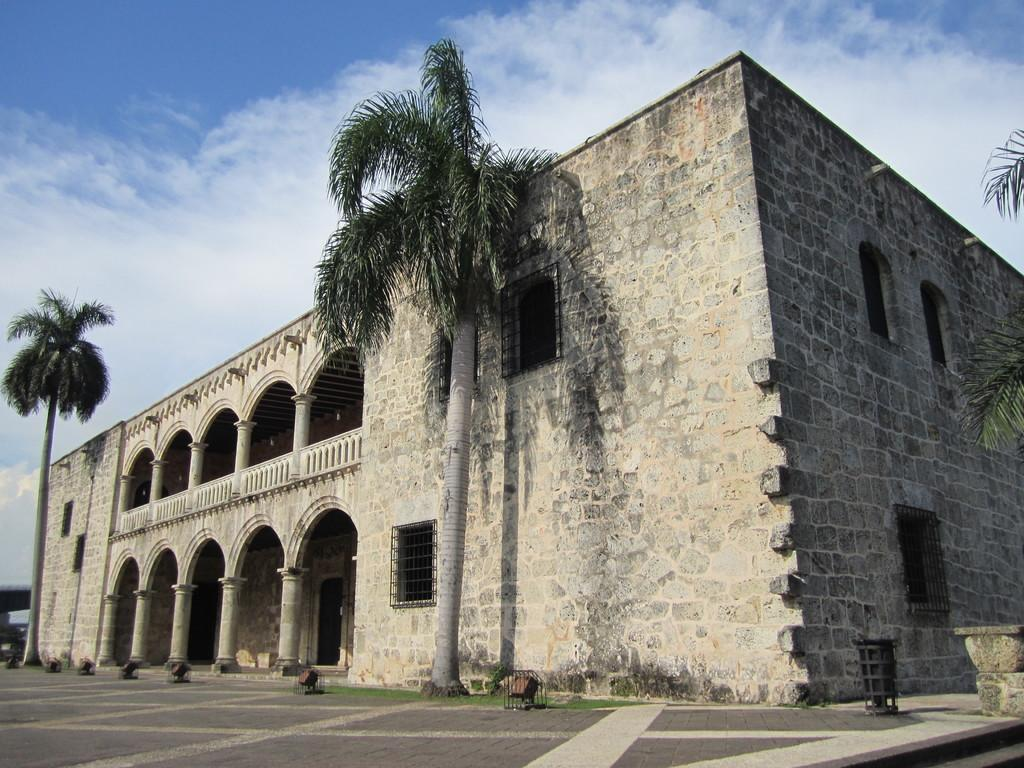What type of building can be seen in the image? There is a building made of stones in the image. What other natural elements are present in the image? Trees are present in the image. Is there any indication of a path or trail in the image? Yes, there is a walking path in the image. What is the color of the sky in the image? The sky is blue in the image. What type of drug can be seen in the image? There is no drug present in the image. Can you describe the type of sofa in the image? There is no sofa present in the image. 